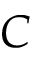Convert formula to latex. <formula><loc_0><loc_0><loc_500><loc_500>C</formula> 